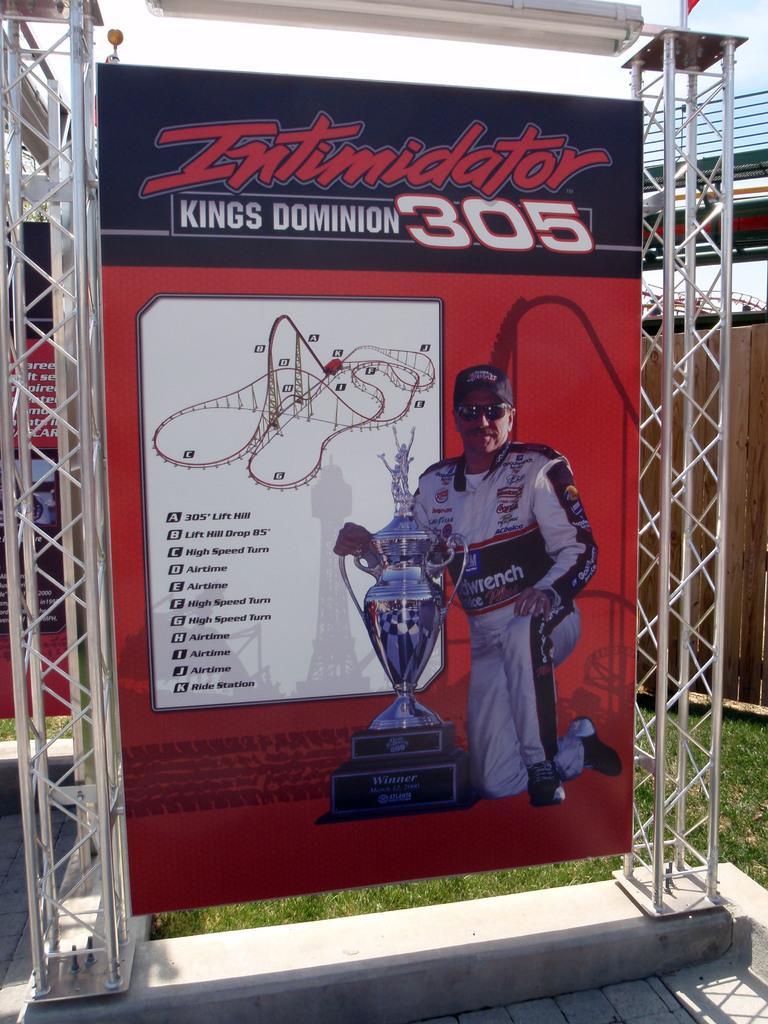<image>
Give a short and clear explanation of the subsequent image. An advertisement for the intimidator kings domain 305 with a man kneeling in the center. 